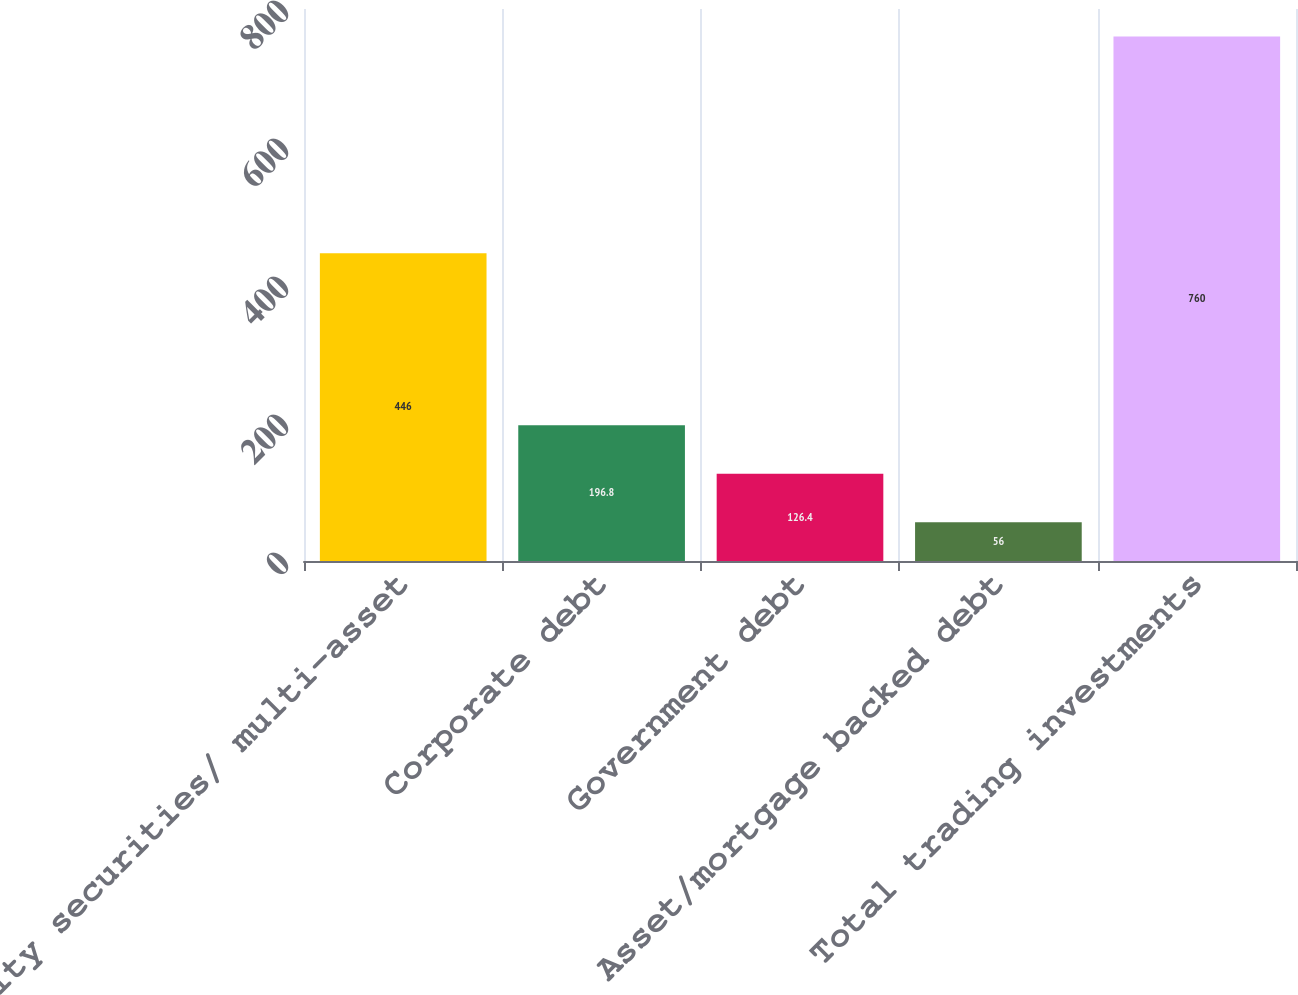Convert chart to OTSL. <chart><loc_0><loc_0><loc_500><loc_500><bar_chart><fcel>Equity securities/ multi-asset<fcel>Corporate debt<fcel>Government debt<fcel>Asset/mortgage backed debt<fcel>Total trading investments<nl><fcel>446<fcel>196.8<fcel>126.4<fcel>56<fcel>760<nl></chart> 